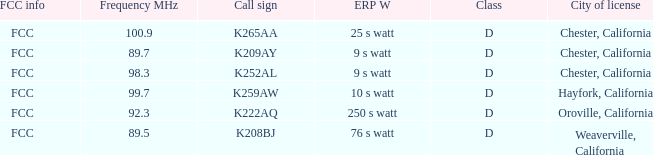Name the call sign with frequency of 89.5 K208BJ. 